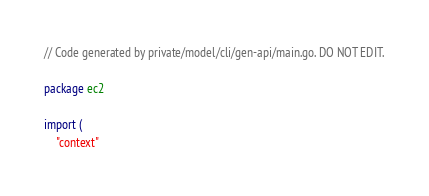Convert code to text. <code><loc_0><loc_0><loc_500><loc_500><_Go_>// Code generated by private/model/cli/gen-api/main.go. DO NOT EDIT.

package ec2

import (
	"context"
</code> 